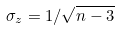<formula> <loc_0><loc_0><loc_500><loc_500>\sigma _ { z } = 1 / \sqrt { n - 3 }</formula> 